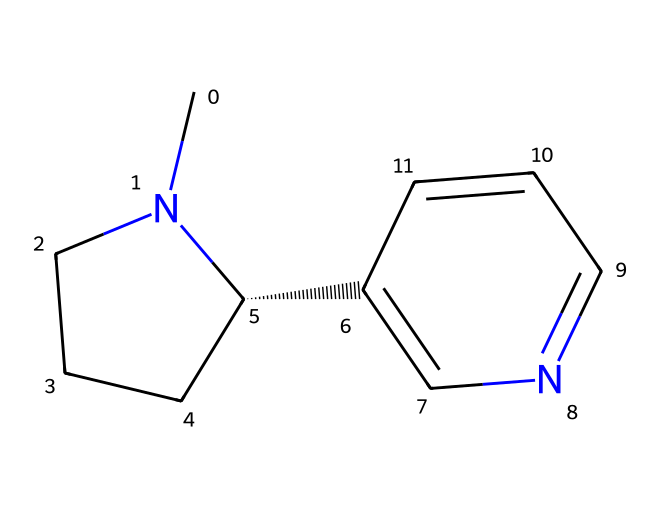What is the molecular formula of nicotine? The SMILES representation indicates the number of each type of atom present in the structure. Counting the carbon (C), nitrogen (N), and hydrogen (H) atoms gives us C10H14N2.
Answer: C10H14N2 How many rings are present in the nicotine structure? Analyzing the chemical structure, we see two distinct rings within the molecule. One is a piperidine ring, and the other is a pyridine ring.
Answer: 2 What type of functional groups are present in nicotine? In the structure of nicotine, there is a nitrogen atom incorporated into the rings, indicating the presence of amine functional groups (specifically pyridine and piperidine).
Answer: amine Does nicotine contain any aromatic systems? By examining the chemical structure, we observe that the pyridine ring possesses a resonance structure and satisfies the definition of aromaticity due to its cyclic conjugated pi electrons.
Answer: yes What is the total number of nitrogen atoms in nicotine? The SMILES representation includes two nitrogen atoms, identified by the "N" characters in the structure.
Answer: 2 What is the predominant nature of nicotine in terms of polarity? Considering the structure’s nitrogen atoms and distribution of bonds, nicotine has polar characteristics due to the presence of nitrogen which attracts electrons.
Answer: polar 